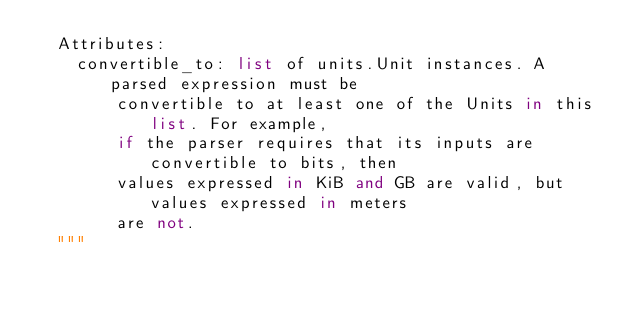<code> <loc_0><loc_0><loc_500><loc_500><_Python_>  Attributes:
    convertible_to: list of units.Unit instances. A parsed expression must be
        convertible to at least one of the Units in this list. For example,
        if the parser requires that its inputs are convertible to bits, then
        values expressed in KiB and GB are valid, but values expressed in meters
        are not.
  """
</code> 